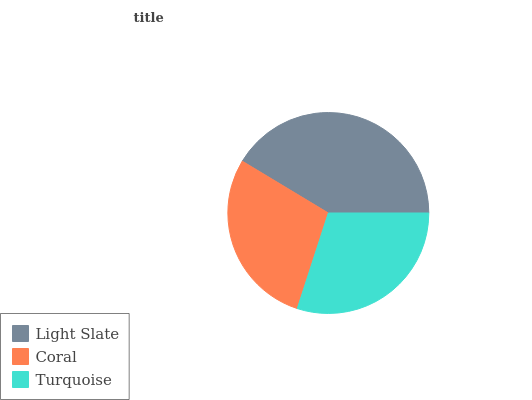Is Coral the minimum?
Answer yes or no. Yes. Is Light Slate the maximum?
Answer yes or no. Yes. Is Turquoise the minimum?
Answer yes or no. No. Is Turquoise the maximum?
Answer yes or no. No. Is Turquoise greater than Coral?
Answer yes or no. Yes. Is Coral less than Turquoise?
Answer yes or no. Yes. Is Coral greater than Turquoise?
Answer yes or no. No. Is Turquoise less than Coral?
Answer yes or no. No. Is Turquoise the high median?
Answer yes or no. Yes. Is Turquoise the low median?
Answer yes or no. Yes. Is Light Slate the high median?
Answer yes or no. No. Is Light Slate the low median?
Answer yes or no. No. 